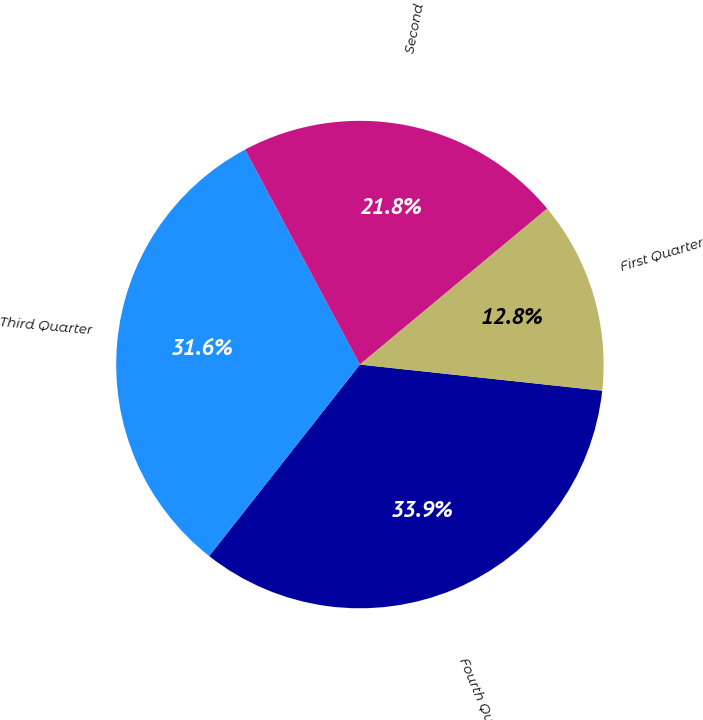Convert chart to OTSL. <chart><loc_0><loc_0><loc_500><loc_500><pie_chart><fcel>Fourth Quarter<fcel>Third Quarter<fcel>Second Quarter<fcel>First Quarter<nl><fcel>33.91%<fcel>31.58%<fcel>21.76%<fcel>12.76%<nl></chart> 